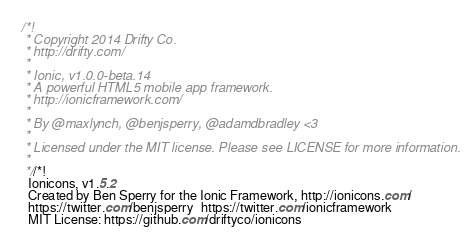Convert code to text. <code><loc_0><loc_0><loc_500><loc_500><_CSS_>/*!
 * Copyright 2014 Drifty Co.
 * http://drifty.com/
 *
 * Ionic, v1.0.0-beta.14
 * A powerful HTML5 mobile app framework.
 * http://ionicframework.com/
 *
 * By @maxlynch, @benjsperry, @adamdbradley <3
 *
 * Licensed under the MIT license. Please see LICENSE for more information.
 *
 *//*!
  Ionicons, v1.5.2
  Created by Ben Sperry for the Ionic Framework, http://ionicons.com/
  https://twitter.com/benjsperry  https://twitter.com/ionicframework
  MIT License: https://github.com/driftyco/ionicons</code> 